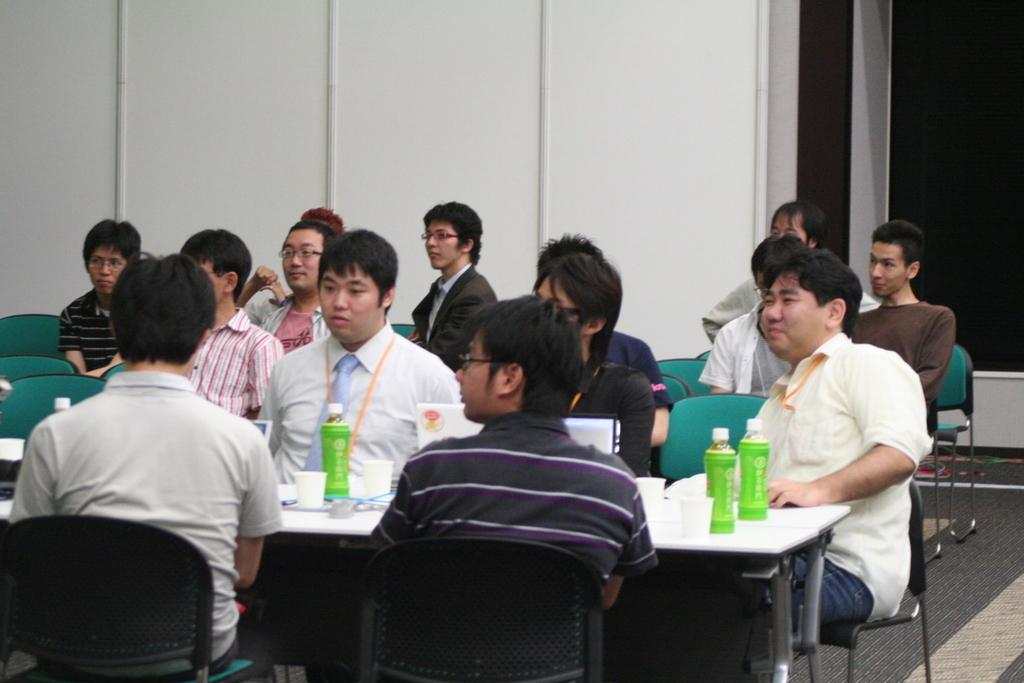How many people are in the image? There is a group of persons in the image. What are the persons doing in the image? The persons are sitting on chairs. Where are the chairs located? The chairs are in a room. What objects can be seen on top of the table in the image? There are bottles and glasses on top of the table. Can you see a nest in the image? There is no nest present in the image. What type of ray is visible in the image? There is no ray present in the image. 